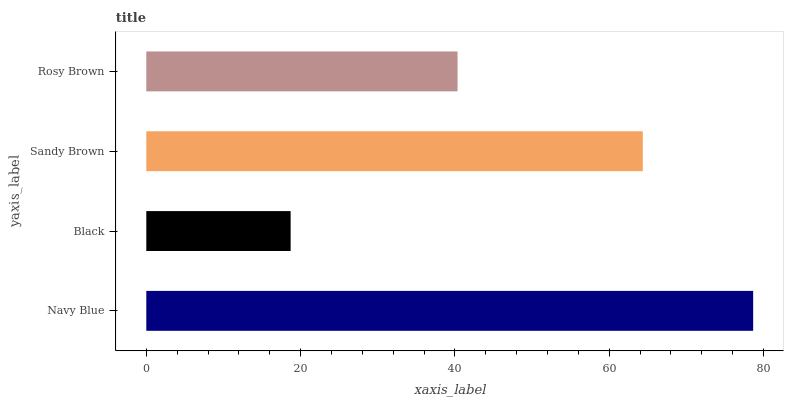Is Black the minimum?
Answer yes or no. Yes. Is Navy Blue the maximum?
Answer yes or no. Yes. Is Sandy Brown the minimum?
Answer yes or no. No. Is Sandy Brown the maximum?
Answer yes or no. No. Is Sandy Brown greater than Black?
Answer yes or no. Yes. Is Black less than Sandy Brown?
Answer yes or no. Yes. Is Black greater than Sandy Brown?
Answer yes or no. No. Is Sandy Brown less than Black?
Answer yes or no. No. Is Sandy Brown the high median?
Answer yes or no. Yes. Is Rosy Brown the low median?
Answer yes or no. Yes. Is Black the high median?
Answer yes or no. No. Is Sandy Brown the low median?
Answer yes or no. No. 